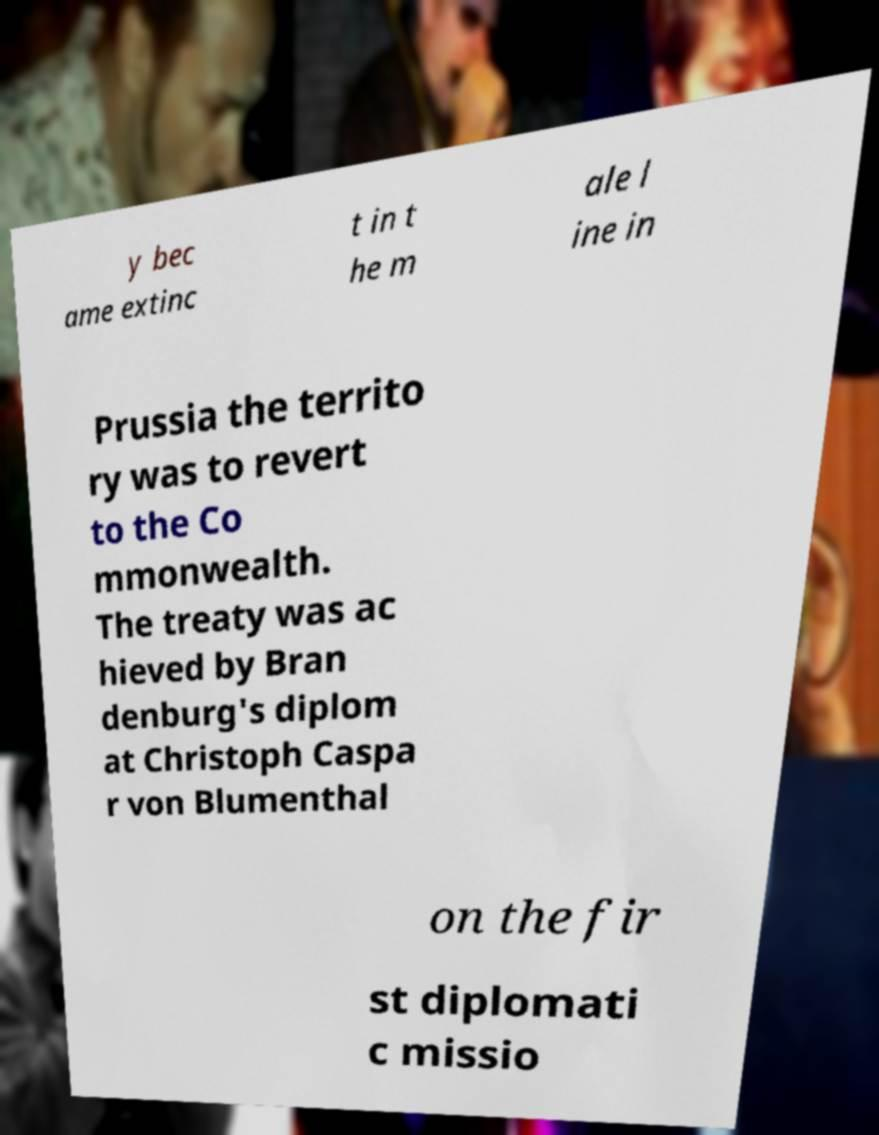Can you accurately transcribe the text from the provided image for me? y bec ame extinc t in t he m ale l ine in Prussia the territo ry was to revert to the Co mmonwealth. The treaty was ac hieved by Bran denburg's diplom at Christoph Caspa r von Blumenthal on the fir st diplomati c missio 